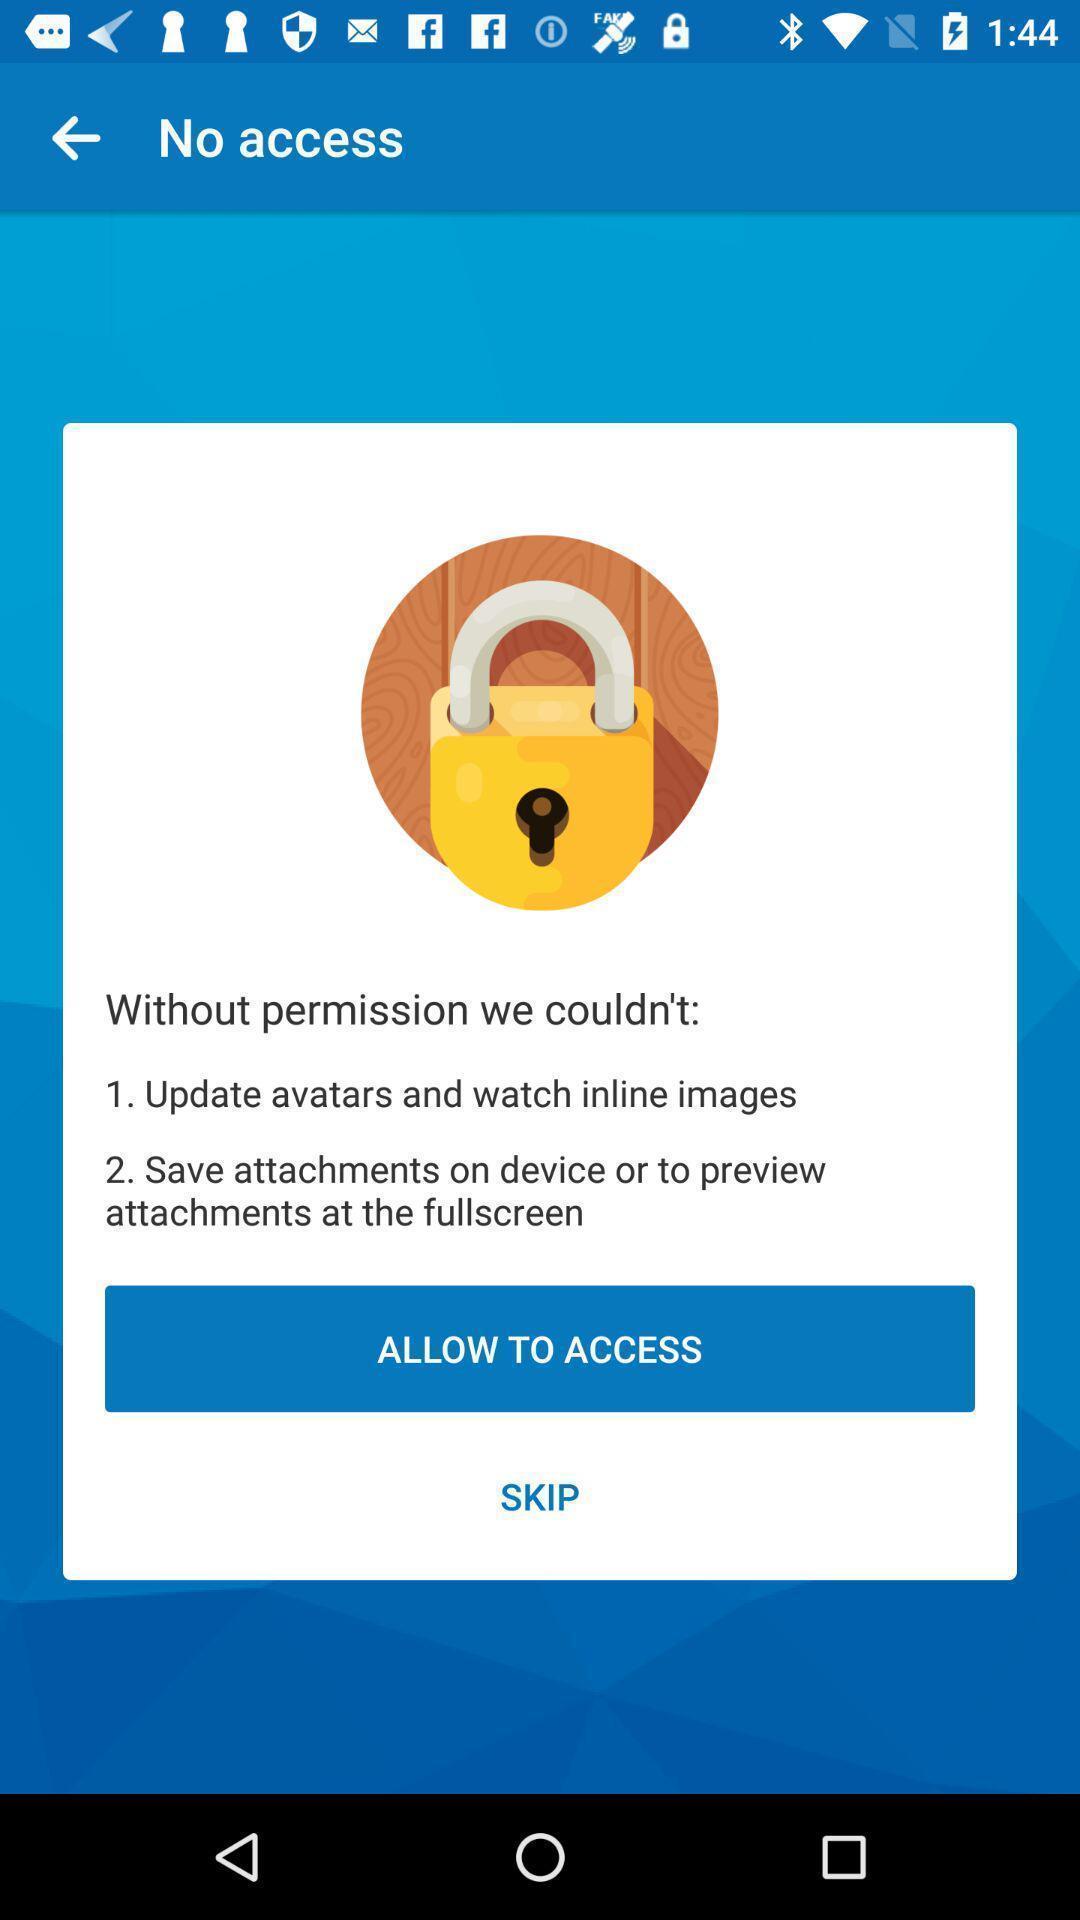Provide a textual representation of this image. Pop-up asking to allow the access. 